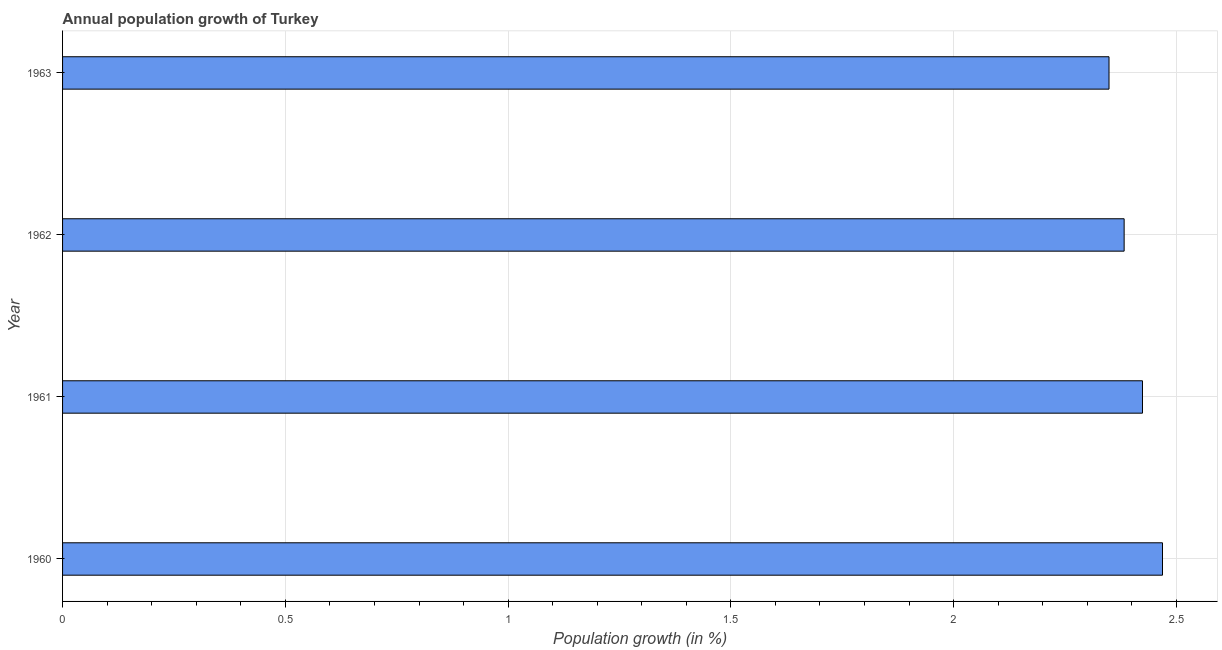What is the title of the graph?
Ensure brevity in your answer.  Annual population growth of Turkey. What is the label or title of the X-axis?
Provide a succinct answer. Population growth (in %). What is the label or title of the Y-axis?
Keep it short and to the point. Year. What is the population growth in 1961?
Provide a short and direct response. 2.42. Across all years, what is the maximum population growth?
Offer a very short reply. 2.47. Across all years, what is the minimum population growth?
Keep it short and to the point. 2.35. In which year was the population growth minimum?
Keep it short and to the point. 1963. What is the sum of the population growth?
Provide a short and direct response. 9.62. What is the difference between the population growth in 1961 and 1962?
Your answer should be compact. 0.04. What is the average population growth per year?
Provide a succinct answer. 2.41. What is the median population growth?
Your answer should be very brief. 2.4. In how many years, is the population growth greater than 1.1 %?
Your response must be concise. 4. What is the ratio of the population growth in 1960 to that in 1963?
Your response must be concise. 1.05. Is the population growth in 1960 less than that in 1962?
Provide a succinct answer. No. Is the difference between the population growth in 1962 and 1963 greater than the difference between any two years?
Make the answer very short. No. What is the difference between the highest and the second highest population growth?
Keep it short and to the point. 0.04. Is the sum of the population growth in 1961 and 1962 greater than the maximum population growth across all years?
Keep it short and to the point. Yes. What is the difference between the highest and the lowest population growth?
Give a very brief answer. 0.12. How many bars are there?
Your answer should be very brief. 4. Are all the bars in the graph horizontal?
Your answer should be very brief. Yes. How many years are there in the graph?
Provide a succinct answer. 4. What is the Population growth (in %) in 1960?
Your response must be concise. 2.47. What is the Population growth (in %) in 1961?
Offer a very short reply. 2.42. What is the Population growth (in %) of 1962?
Provide a short and direct response. 2.38. What is the Population growth (in %) in 1963?
Your answer should be very brief. 2.35. What is the difference between the Population growth (in %) in 1960 and 1961?
Provide a short and direct response. 0.04. What is the difference between the Population growth (in %) in 1960 and 1962?
Your response must be concise. 0.09. What is the difference between the Population growth (in %) in 1960 and 1963?
Your response must be concise. 0.12. What is the difference between the Population growth (in %) in 1961 and 1962?
Give a very brief answer. 0.04. What is the difference between the Population growth (in %) in 1961 and 1963?
Offer a very short reply. 0.08. What is the difference between the Population growth (in %) in 1962 and 1963?
Your response must be concise. 0.03. What is the ratio of the Population growth (in %) in 1960 to that in 1961?
Ensure brevity in your answer.  1.02. What is the ratio of the Population growth (in %) in 1960 to that in 1962?
Your answer should be very brief. 1.04. What is the ratio of the Population growth (in %) in 1960 to that in 1963?
Offer a very short reply. 1.05. What is the ratio of the Population growth (in %) in 1961 to that in 1963?
Ensure brevity in your answer.  1.03. 